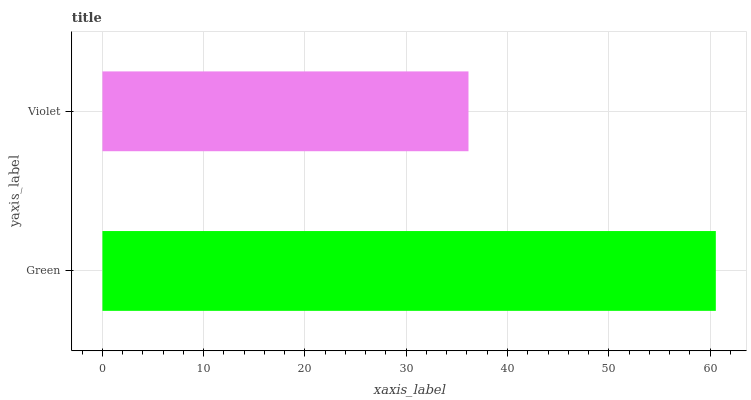Is Violet the minimum?
Answer yes or no. Yes. Is Green the maximum?
Answer yes or no. Yes. Is Violet the maximum?
Answer yes or no. No. Is Green greater than Violet?
Answer yes or no. Yes. Is Violet less than Green?
Answer yes or no. Yes. Is Violet greater than Green?
Answer yes or no. No. Is Green less than Violet?
Answer yes or no. No. Is Green the high median?
Answer yes or no. Yes. Is Violet the low median?
Answer yes or no. Yes. Is Violet the high median?
Answer yes or no. No. Is Green the low median?
Answer yes or no. No. 